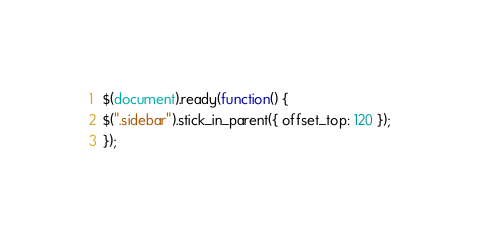Convert code to text. <code><loc_0><loc_0><loc_500><loc_500><_JavaScript_>$(document).ready(function() {
$(".sidebar").stick_in_parent({ offset_top: 120 });
});
</code> 